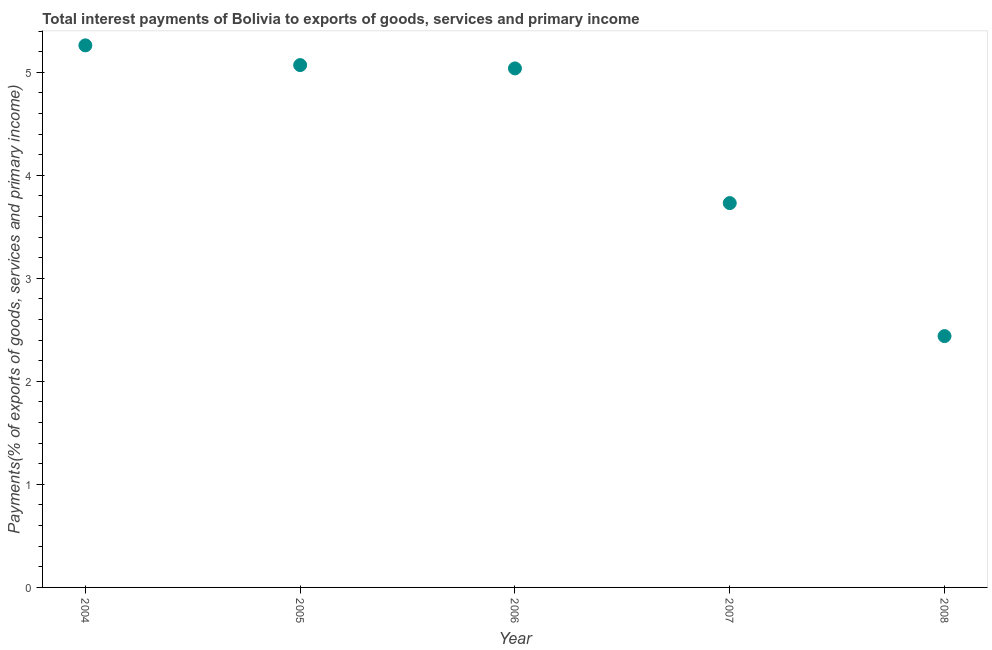What is the total interest payments on external debt in 2008?
Your answer should be very brief. 2.44. Across all years, what is the maximum total interest payments on external debt?
Provide a short and direct response. 5.26. Across all years, what is the minimum total interest payments on external debt?
Offer a very short reply. 2.44. What is the sum of the total interest payments on external debt?
Give a very brief answer. 21.54. What is the difference between the total interest payments on external debt in 2004 and 2008?
Ensure brevity in your answer.  2.82. What is the average total interest payments on external debt per year?
Your answer should be very brief. 4.31. What is the median total interest payments on external debt?
Ensure brevity in your answer.  5.04. In how many years, is the total interest payments on external debt greater than 2.8 %?
Your answer should be very brief. 4. What is the ratio of the total interest payments on external debt in 2005 to that in 2006?
Your response must be concise. 1.01. Is the total interest payments on external debt in 2006 less than that in 2008?
Provide a succinct answer. No. Is the difference between the total interest payments on external debt in 2004 and 2005 greater than the difference between any two years?
Ensure brevity in your answer.  No. What is the difference between the highest and the second highest total interest payments on external debt?
Offer a very short reply. 0.19. Is the sum of the total interest payments on external debt in 2005 and 2008 greater than the maximum total interest payments on external debt across all years?
Give a very brief answer. Yes. What is the difference between the highest and the lowest total interest payments on external debt?
Ensure brevity in your answer.  2.82. How many dotlines are there?
Offer a very short reply. 1. Does the graph contain grids?
Offer a very short reply. No. What is the title of the graph?
Offer a very short reply. Total interest payments of Bolivia to exports of goods, services and primary income. What is the label or title of the Y-axis?
Your response must be concise. Payments(% of exports of goods, services and primary income). What is the Payments(% of exports of goods, services and primary income) in 2004?
Provide a short and direct response. 5.26. What is the Payments(% of exports of goods, services and primary income) in 2005?
Provide a short and direct response. 5.07. What is the Payments(% of exports of goods, services and primary income) in 2006?
Your answer should be very brief. 5.04. What is the Payments(% of exports of goods, services and primary income) in 2007?
Your response must be concise. 3.73. What is the Payments(% of exports of goods, services and primary income) in 2008?
Offer a very short reply. 2.44. What is the difference between the Payments(% of exports of goods, services and primary income) in 2004 and 2005?
Ensure brevity in your answer.  0.19. What is the difference between the Payments(% of exports of goods, services and primary income) in 2004 and 2006?
Your response must be concise. 0.22. What is the difference between the Payments(% of exports of goods, services and primary income) in 2004 and 2007?
Provide a succinct answer. 1.53. What is the difference between the Payments(% of exports of goods, services and primary income) in 2004 and 2008?
Your response must be concise. 2.82. What is the difference between the Payments(% of exports of goods, services and primary income) in 2005 and 2006?
Ensure brevity in your answer.  0.03. What is the difference between the Payments(% of exports of goods, services and primary income) in 2005 and 2007?
Ensure brevity in your answer.  1.34. What is the difference between the Payments(% of exports of goods, services and primary income) in 2005 and 2008?
Your answer should be compact. 2.63. What is the difference between the Payments(% of exports of goods, services and primary income) in 2006 and 2007?
Ensure brevity in your answer.  1.31. What is the difference between the Payments(% of exports of goods, services and primary income) in 2006 and 2008?
Keep it short and to the point. 2.6. What is the difference between the Payments(% of exports of goods, services and primary income) in 2007 and 2008?
Provide a short and direct response. 1.29. What is the ratio of the Payments(% of exports of goods, services and primary income) in 2004 to that in 2005?
Your answer should be compact. 1.04. What is the ratio of the Payments(% of exports of goods, services and primary income) in 2004 to that in 2006?
Ensure brevity in your answer.  1.04. What is the ratio of the Payments(% of exports of goods, services and primary income) in 2004 to that in 2007?
Ensure brevity in your answer.  1.41. What is the ratio of the Payments(% of exports of goods, services and primary income) in 2004 to that in 2008?
Your answer should be very brief. 2.16. What is the ratio of the Payments(% of exports of goods, services and primary income) in 2005 to that in 2006?
Provide a short and direct response. 1.01. What is the ratio of the Payments(% of exports of goods, services and primary income) in 2005 to that in 2007?
Your answer should be compact. 1.36. What is the ratio of the Payments(% of exports of goods, services and primary income) in 2005 to that in 2008?
Make the answer very short. 2.08. What is the ratio of the Payments(% of exports of goods, services and primary income) in 2006 to that in 2007?
Give a very brief answer. 1.35. What is the ratio of the Payments(% of exports of goods, services and primary income) in 2006 to that in 2008?
Offer a terse response. 2.06. What is the ratio of the Payments(% of exports of goods, services and primary income) in 2007 to that in 2008?
Keep it short and to the point. 1.53. 